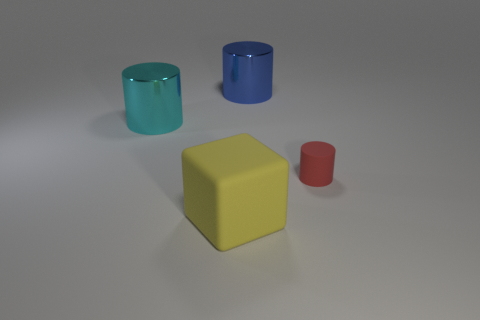Are there any other things that have the same shape as the yellow rubber object?
Offer a very short reply. No. What number of things are either cylinders behind the red matte cylinder or large rubber cubes?
Offer a very short reply. 3. There is a matte thing that is to the right of the big shiny thing right of the matte cube; what shape is it?
Provide a succinct answer. Cylinder. Is the number of large blue cylinders to the left of the cyan metal thing less than the number of red rubber cylinders that are behind the yellow matte thing?
Give a very brief answer. Yes. The other matte thing that is the same shape as the big blue thing is what size?
Your response must be concise. Small. Is there anything else that has the same size as the matte cylinder?
Offer a very short reply. No. What number of objects are either cylinders that are right of the cyan object or objects that are behind the small matte thing?
Keep it short and to the point. 3. Do the red cylinder and the blue metallic object have the same size?
Your answer should be very brief. No. Is the number of red rubber cylinders greater than the number of purple metal things?
Provide a short and direct response. Yes. How many other things are the same color as the rubber cylinder?
Offer a very short reply. 0. 